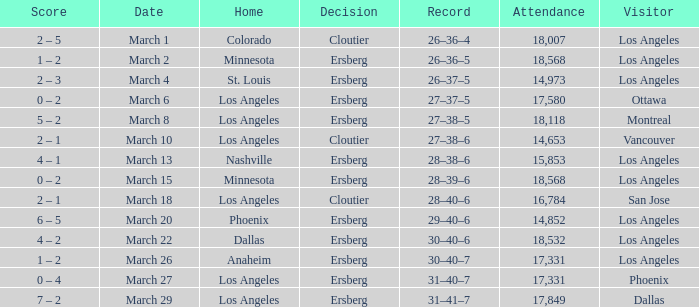Who played as the home team on the 13th of march? Nashville. 